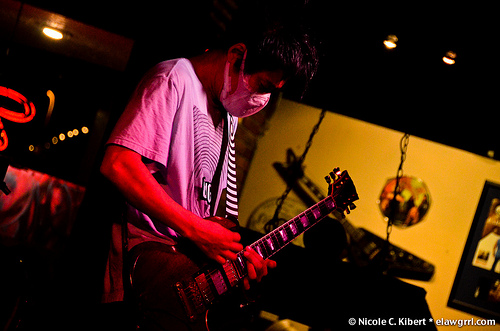<image>
Is there a person behind the guitar? Yes. From this viewpoint, the person is positioned behind the guitar, with the guitar partially or fully occluding the person. Is there a guitar next to the picture? Yes. The guitar is positioned adjacent to the picture, located nearby in the same general area. 